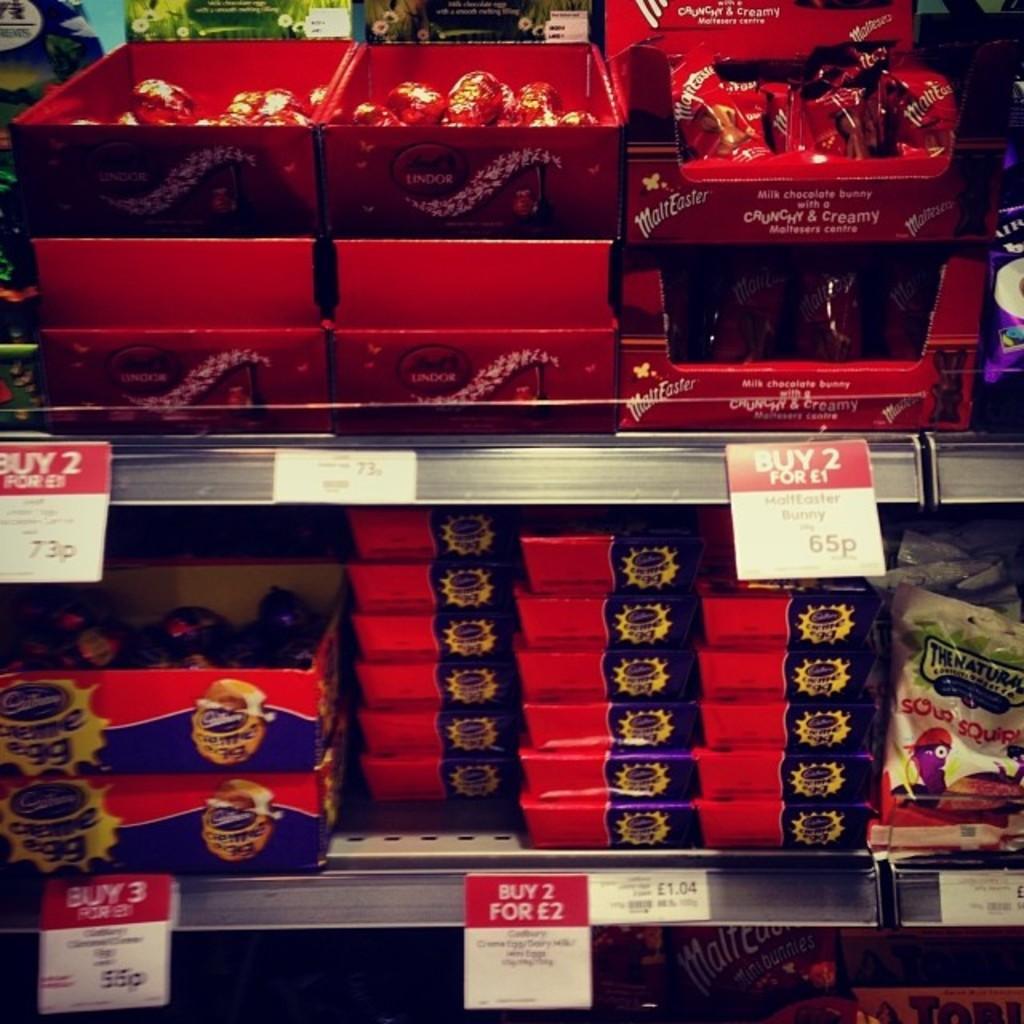In one or two sentences, can you explain what this image depicts? In this image in the front there are boxes with some text and images on it and there are papers with some text written on it and the boxes are in the shelfs. 